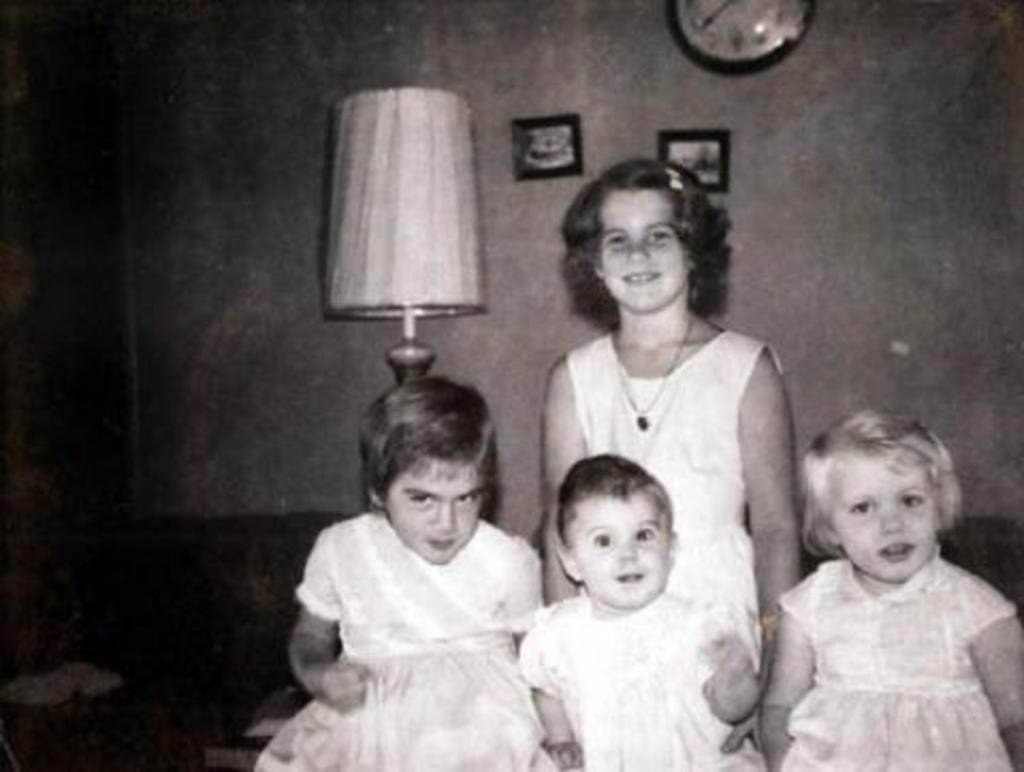In one or two sentences, can you explain what this image depicts? In this image in front there are four children. Behind them there is a lamp. There are photo frames and a clock on the wall. On the left side of the image there are some objects. 